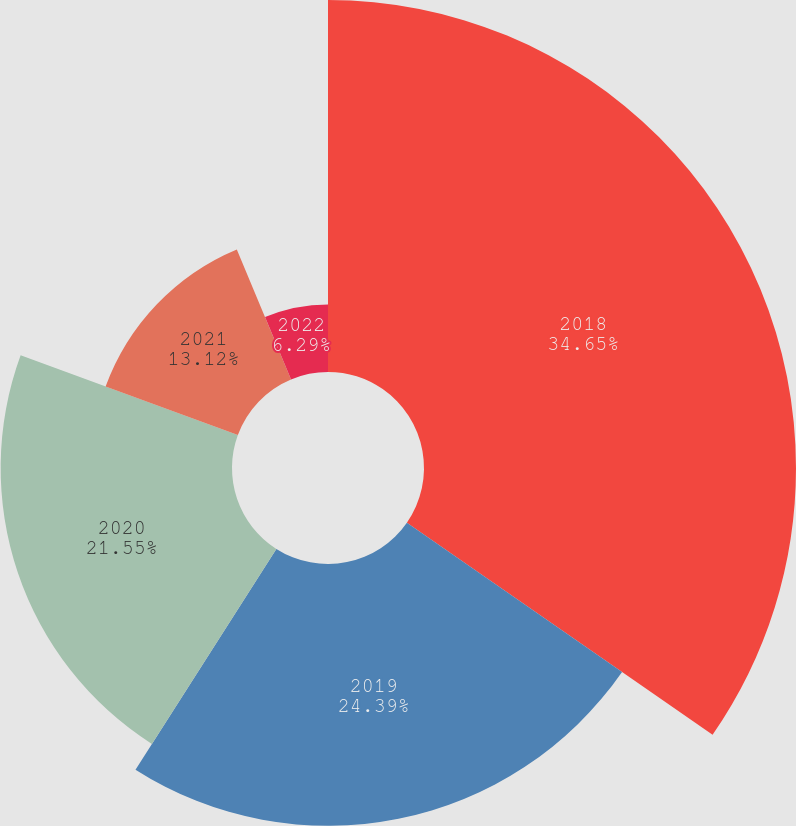<chart> <loc_0><loc_0><loc_500><loc_500><pie_chart><fcel>2018<fcel>2019<fcel>2020<fcel>2021<fcel>2022<nl><fcel>34.65%<fcel>24.39%<fcel>21.55%<fcel>13.12%<fcel>6.29%<nl></chart> 